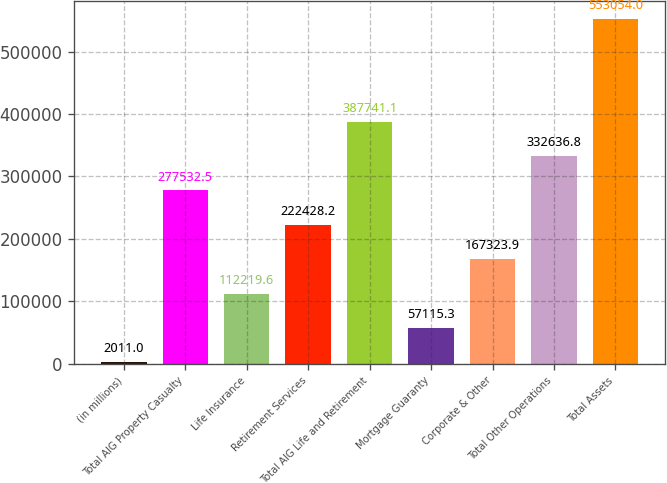Convert chart. <chart><loc_0><loc_0><loc_500><loc_500><bar_chart><fcel>(in millions)<fcel>Total AIG Property Casualty<fcel>Life Insurance<fcel>Retirement Services<fcel>Total AIG Life and Retirement<fcel>Mortgage Guaranty<fcel>Corporate & Other<fcel>Total Other Operations<fcel>Total Assets<nl><fcel>2011<fcel>277532<fcel>112220<fcel>222428<fcel>387741<fcel>57115.3<fcel>167324<fcel>332637<fcel>553054<nl></chart> 